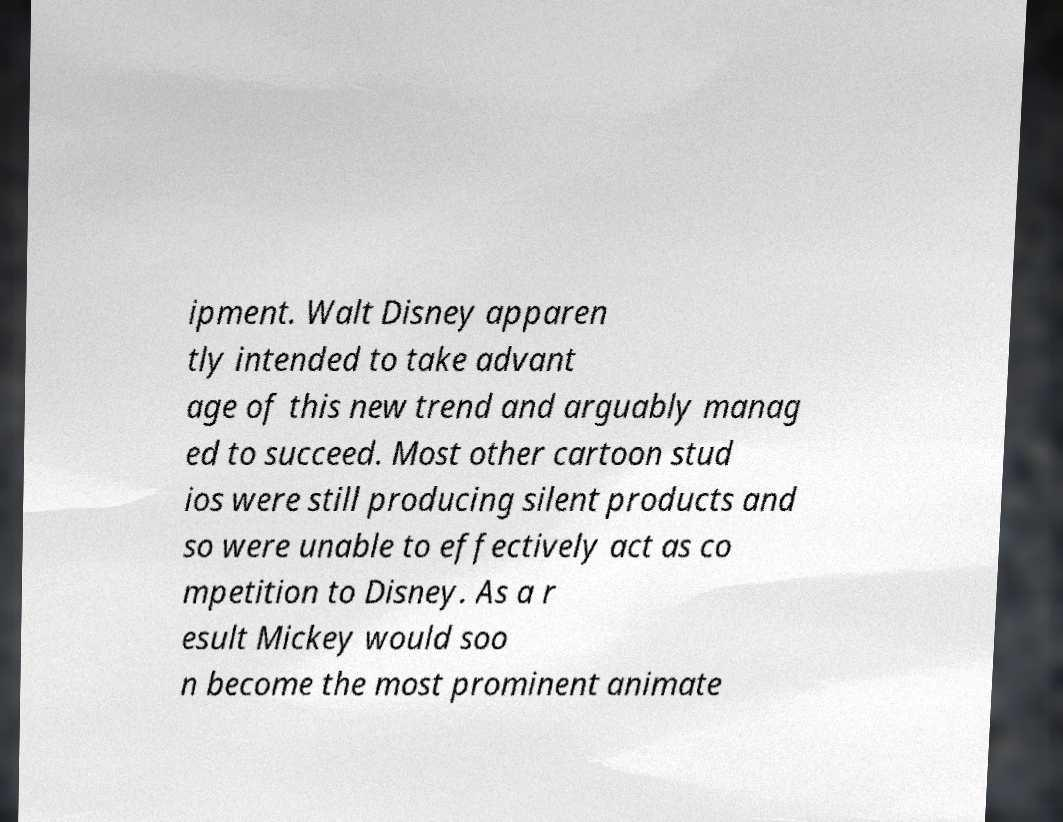For documentation purposes, I need the text within this image transcribed. Could you provide that? ipment. Walt Disney apparen tly intended to take advant age of this new trend and arguably manag ed to succeed. Most other cartoon stud ios were still producing silent products and so were unable to effectively act as co mpetition to Disney. As a r esult Mickey would soo n become the most prominent animate 